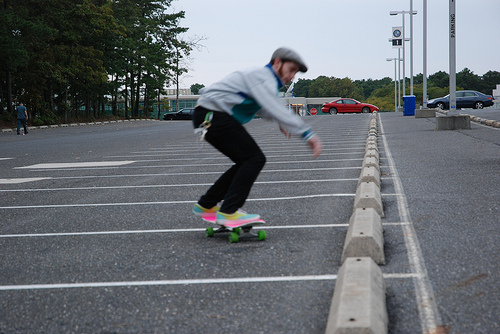What kind of skateboard is being used? The skateboard in use appears to be a standard street skateboard with a flat deck and small, hard wheels, which is ideal for tricks and riding on smooth pavement like this parking lot. 